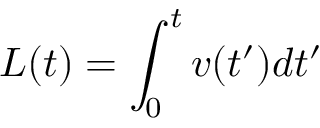Convert formula to latex. <formula><loc_0><loc_0><loc_500><loc_500>L ( t ) = \int _ { 0 } ^ { t } v ( t ^ { \prime } ) d t ^ { \prime }</formula> 